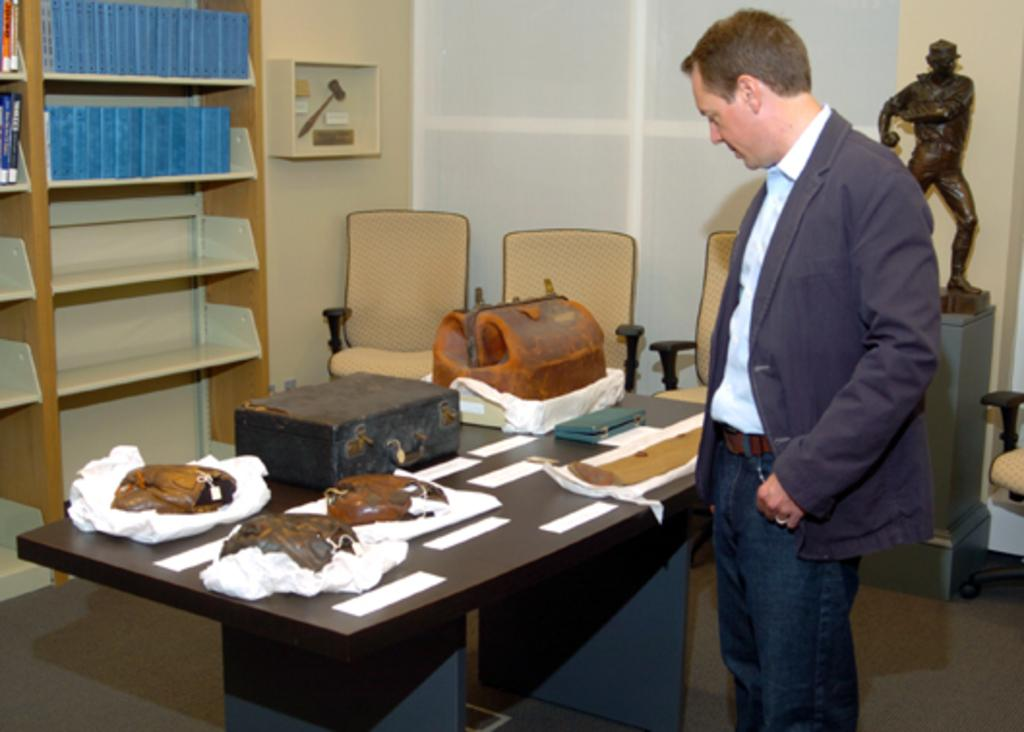What is the main subject of the image? There is a man standing in the image. What is the man doing in the image? The man is looking at objects on a table. What type of items can be seen on a bookshelf in the image? There are books on a bookshelf in the image. What type of furniture is present in the image? There are chairs in the image. What can be seen in the background of the image? There is a statue in the background of the image. What color are the girl's toenails in the image? There is no girl present in the image, so we cannot determine the color of her toenails. 